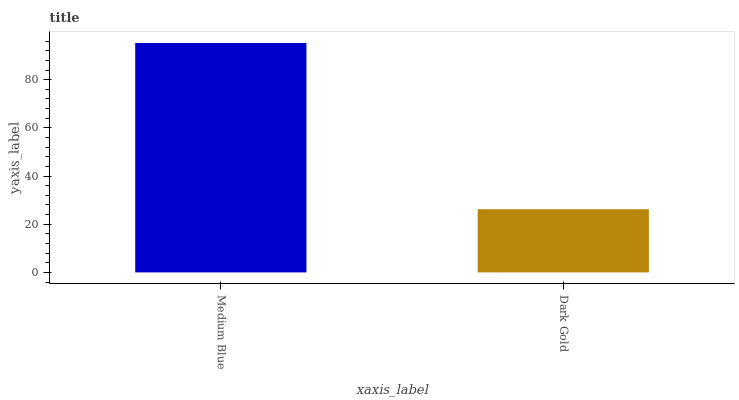Is Dark Gold the minimum?
Answer yes or no. Yes. Is Medium Blue the maximum?
Answer yes or no. Yes. Is Dark Gold the maximum?
Answer yes or no. No. Is Medium Blue greater than Dark Gold?
Answer yes or no. Yes. Is Dark Gold less than Medium Blue?
Answer yes or no. Yes. Is Dark Gold greater than Medium Blue?
Answer yes or no. No. Is Medium Blue less than Dark Gold?
Answer yes or no. No. Is Medium Blue the high median?
Answer yes or no. Yes. Is Dark Gold the low median?
Answer yes or no. Yes. Is Dark Gold the high median?
Answer yes or no. No. Is Medium Blue the low median?
Answer yes or no. No. 